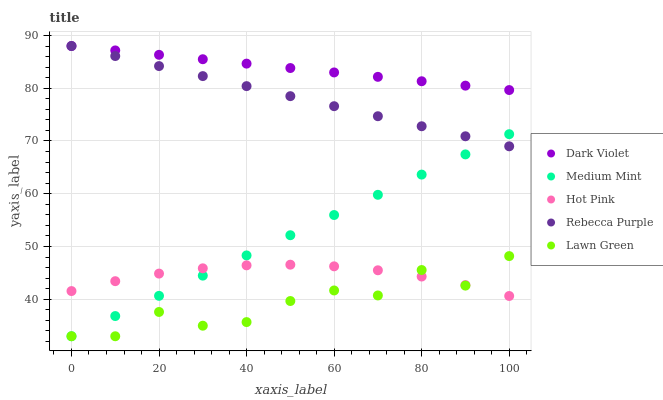Does Lawn Green have the minimum area under the curve?
Answer yes or no. Yes. Does Dark Violet have the maximum area under the curve?
Answer yes or no. Yes. Does Hot Pink have the minimum area under the curve?
Answer yes or no. No. Does Hot Pink have the maximum area under the curve?
Answer yes or no. No. Is Dark Violet the smoothest?
Answer yes or no. Yes. Is Lawn Green the roughest?
Answer yes or no. Yes. Is Hot Pink the smoothest?
Answer yes or no. No. Is Hot Pink the roughest?
Answer yes or no. No. Does Medium Mint have the lowest value?
Answer yes or no. Yes. Does Hot Pink have the lowest value?
Answer yes or no. No. Does Dark Violet have the highest value?
Answer yes or no. Yes. Does Lawn Green have the highest value?
Answer yes or no. No. Is Medium Mint less than Dark Violet?
Answer yes or no. Yes. Is Dark Violet greater than Hot Pink?
Answer yes or no. Yes. Does Lawn Green intersect Medium Mint?
Answer yes or no. Yes. Is Lawn Green less than Medium Mint?
Answer yes or no. No. Is Lawn Green greater than Medium Mint?
Answer yes or no. No. Does Medium Mint intersect Dark Violet?
Answer yes or no. No. 